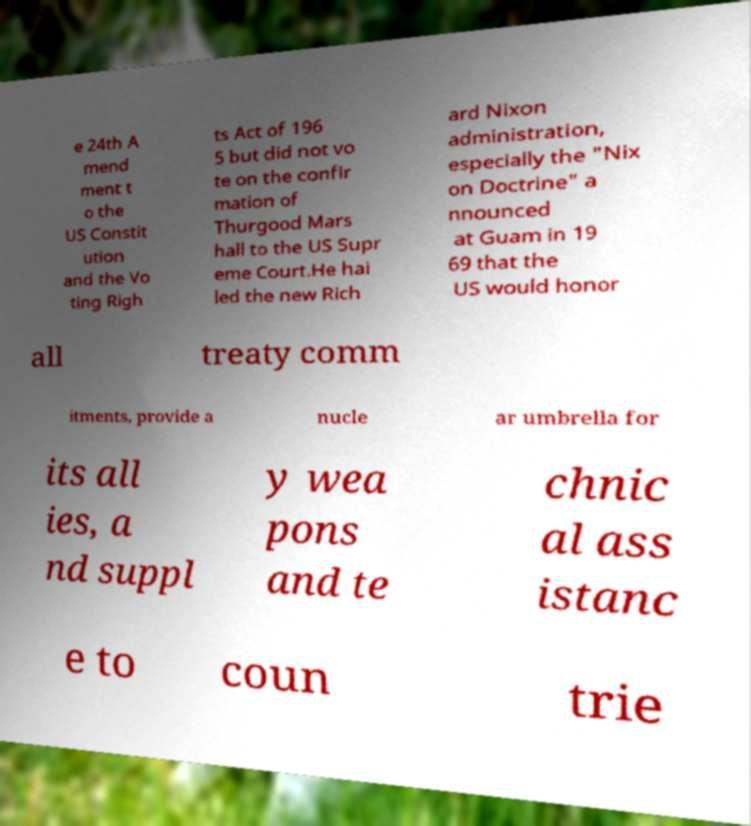Please read and relay the text visible in this image. What does it say? e 24th A mend ment t o the US Constit ution and the Vo ting Righ ts Act of 196 5 but did not vo te on the confir mation of Thurgood Mars hall to the US Supr eme Court.He hai led the new Rich ard Nixon administration, especially the "Nix on Doctrine" a nnounced at Guam in 19 69 that the US would honor all treaty comm itments, provide a nucle ar umbrella for its all ies, a nd suppl y wea pons and te chnic al ass istanc e to coun trie 